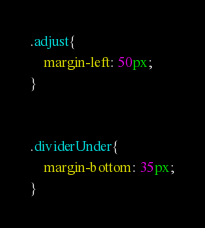<code> <loc_0><loc_0><loc_500><loc_500><_CSS_>.adjust{
	margin-left: 50px;
}


.dividerUnder{
	margin-bottom: 35px;
}</code> 